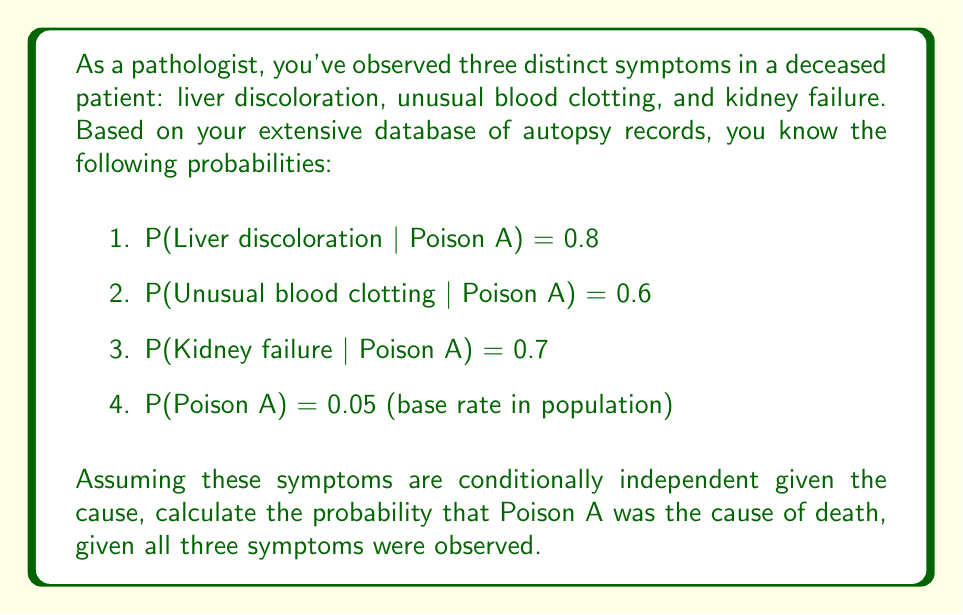Solve this math problem. To solve this inverse problem, we'll use Bayes' theorem and the assumption of conditional independence.

Step 1: Define our events
Let A = Poison A is the cause of death
Let B = Liver discoloration
Let C = Unusual blood clotting
Let D = Kidney failure

Step 2: Write out Bayes' theorem
$$P(A|B,C,D) = \frac{P(B,C,D|A) \cdot P(A)}{P(B,C,D)}$$

Step 3: Use conditional independence to simplify P(B,C,D|A)
$$P(B,C,D|A) = P(B|A) \cdot P(C|A) \cdot P(D|A) = 0.8 \cdot 0.6 \cdot 0.7 = 0.336$$

Step 4: Calculate P(B,C,D) using the law of total probability
$$P(B,C,D) = P(B,C,D|A) \cdot P(A) + P(B,C,D|\text{not A}) \cdot P(\text{not A})$$

We don't have P(B,C,D|not A), but we can approximate it as much smaller than P(B,C,D|A). Let's assume it's 0.01.

$$P(B,C,D) = 0.336 \cdot 0.05 + 0.01 \cdot 0.95 = 0.0168 + 0.0095 = 0.0263$$

Step 5: Apply Bayes' theorem
$$P(A|B,C,D) = \frac{0.336 \cdot 0.05}{0.0263} \approx 0.6388$$

Therefore, the probability that Poison A was the cause of death, given all three symptoms, is approximately 0.6388 or 63.88%.
Answer: 0.6388 